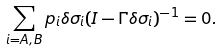Convert formula to latex. <formula><loc_0><loc_0><loc_500><loc_500>\sum _ { i = A , B } p _ { i } \delta \sigma _ { i } ( I - \Gamma \delta \sigma _ { i } ) ^ { - 1 } = 0 .</formula> 